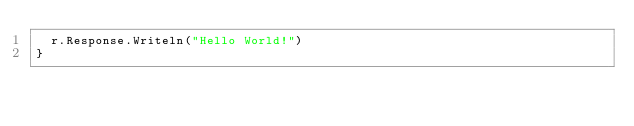Convert code to text. <code><loc_0><loc_0><loc_500><loc_500><_Go_>	r.Response.Writeln("Hello World!")
}
</code> 